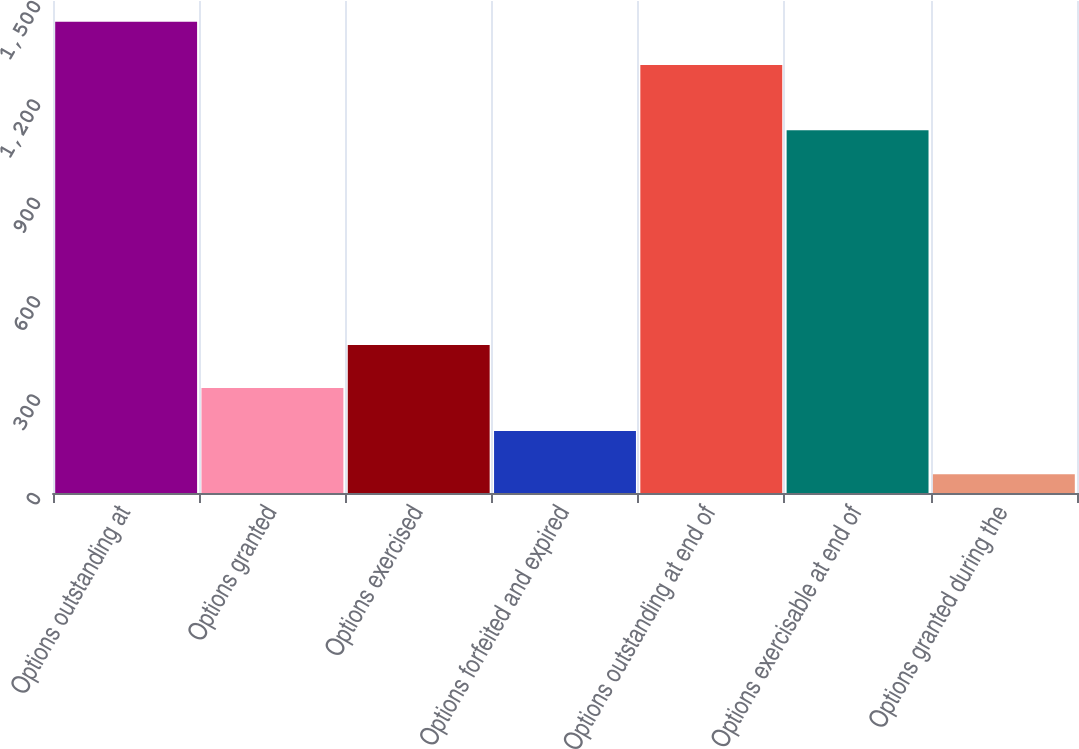Convert chart to OTSL. <chart><loc_0><loc_0><loc_500><loc_500><bar_chart><fcel>Options outstanding at<fcel>Options granted<fcel>Options exercised<fcel>Options forfeited and expired<fcel>Options outstanding at end of<fcel>Options exercisable at end of<fcel>Options granted during the<nl><fcel>1436.37<fcel>320.08<fcel>451.45<fcel>188.71<fcel>1305<fcel>1106<fcel>57.34<nl></chart> 